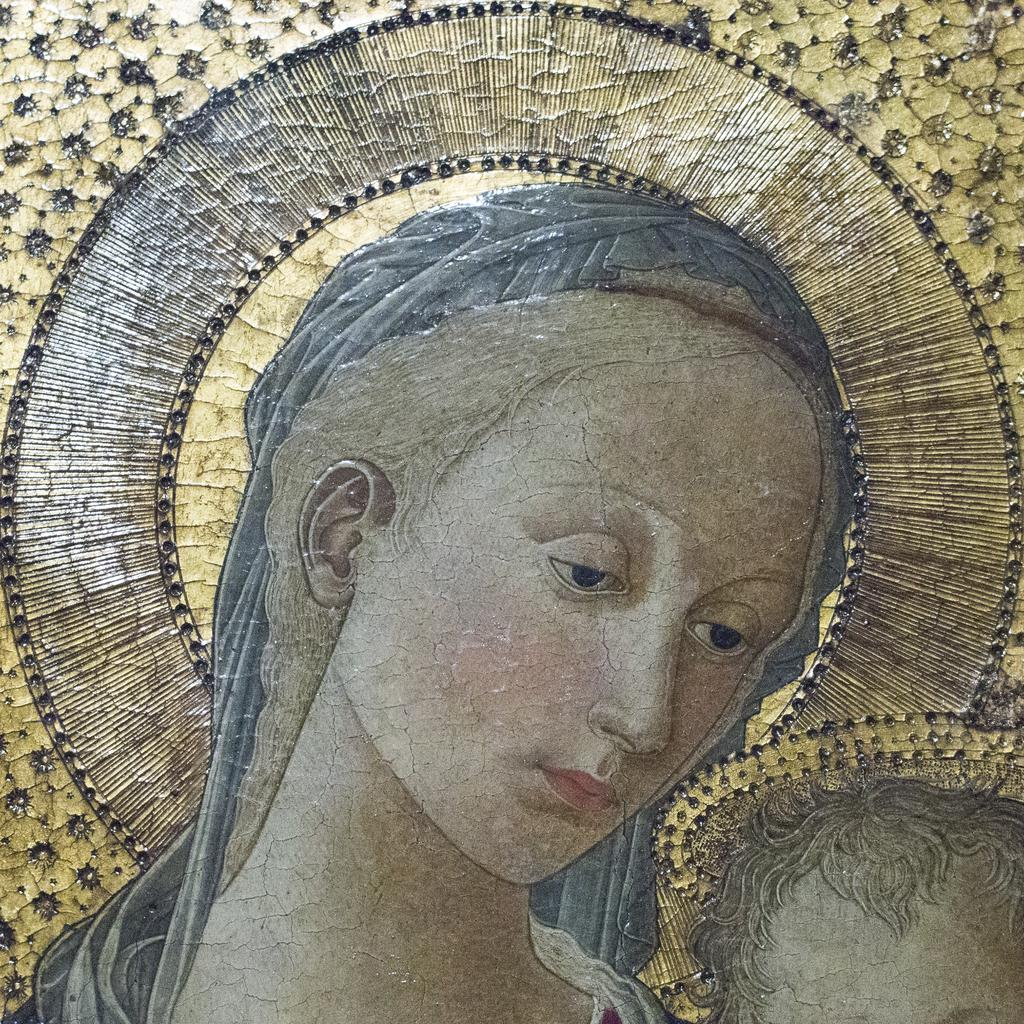What is the main subject of the image? There is a depiction of a woman in the image. Can you describe any additional features or elements in the image? There is a design present in the image. What type of tools does the carpenter use in the image? There is no carpenter present in the image, so it is not possible to answer that question. 